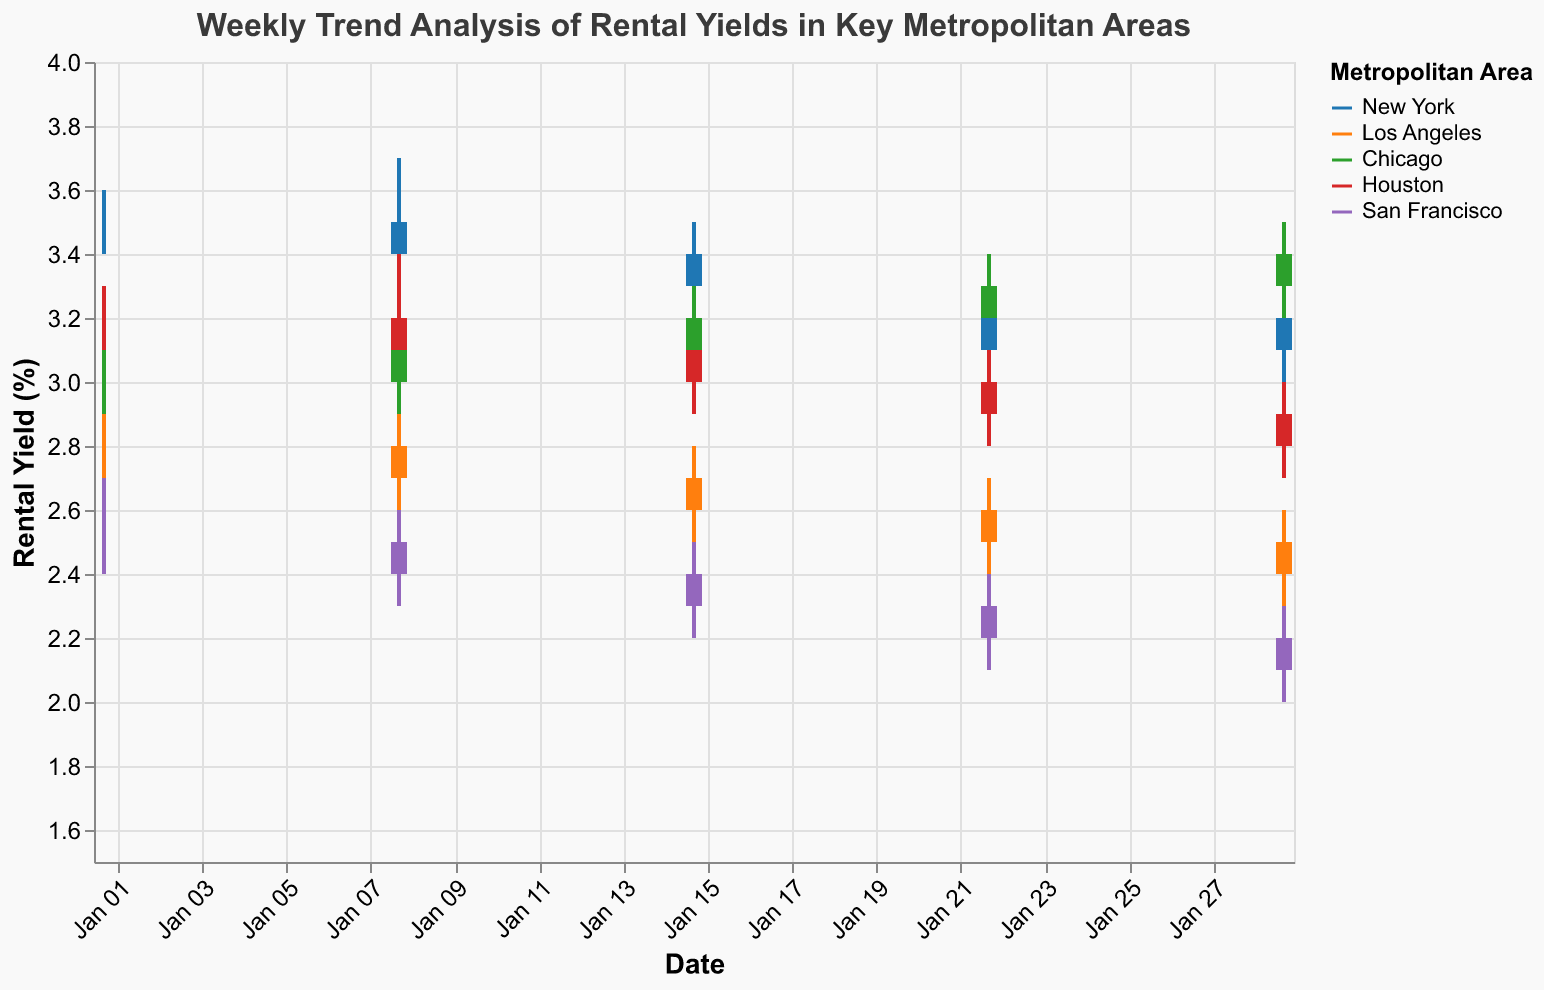What's the overall trend in the rental yields for New York during January 2023? The candlestick bars for New York show a consistent decrease in the "Close" value from January 1 (3.5%) to January 29 (3.2%). This signals a downward trend in rental yields for New York over the month.
Answer: Downward trend Which metropolitan area had the highest rental yield at the end of January 2023? Looking at the final date, January 29, Chicago has the highest "Close" value of 3.4% compared to other cities: New York (3.2%), Los Angeles (2.4%), Houston (2.8%), and San Francisco (2.1%).
Answer: Chicago How did Chicago's rental yield evolve over the four weeks of January 2023? The rental yield for Chicago showed an upward trend, starting at 3.0% on January 1 and gradually increasing to 3.4% by January 29. Each week, the "Close" value increased by around 0.1% or 0.2%.
Answer: Upward trend What is the range of rental yields for Houston on January 8, 2023? For Houston on January 8, the "Low" value is 3.0% and the "High" value is 3.4%. The range is calculated as High minus Low (3.4% - 3.0% = 0.4%).
Answer: 0.4% Compare the rental yields trend between Los Angeles and San Francisco during January 2023. Both Los Angeles and San Francisco show a declining trend in rental yields. Los Angeles started at 2.8% (January 1) and dropped to 2.4% (January 29), while San Francisco declined from 2.5% to 2.1% over the same period.
Answer: Both declined Which location had the greatest weekly fluctuation in rental yields within January 2023? To determine the greatest weekly fluctuation, observe the length of the candlestick bars (difference between "High" and "Low") across all locations. New York on January 8 had the greatest fluctuation where "High" was 3.7% and "Low" was 3.3%, a difference of 0.4%.
Answer: New York (Jan 8) Did any location show an increase in rental yields during the last week of January 2023? Observing the bars from January 22 to January 29, only New York shows an increase as its "Close" value rose from 3.1% to 3.2%.
Answer: New York Which location had the lowest rental yield at any point during January 2023? San Francisco had the lowest rental yield with a "Close" value of 2.1% on January 29, which is lower than any other recorded rental yield for the month.
Answer: San Francisco Between which dates did New York experience the largest weekly drop in rental yields? From January 15 to January 22, New York's rental yields dropped from a "Close" value of 3.3% to 3.1%, indicating the largest weekly drop of 0.2%.
Answer: Jan 15 to Jan 22 